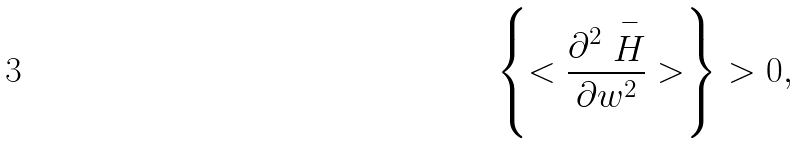Convert formula to latex. <formula><loc_0><loc_0><loc_500><loc_500>\left \{ < \frac { \partial ^ { 2 } \stackrel { - } { H } } { \partial w ^ { 2 } } > \right \} > 0 ,</formula> 